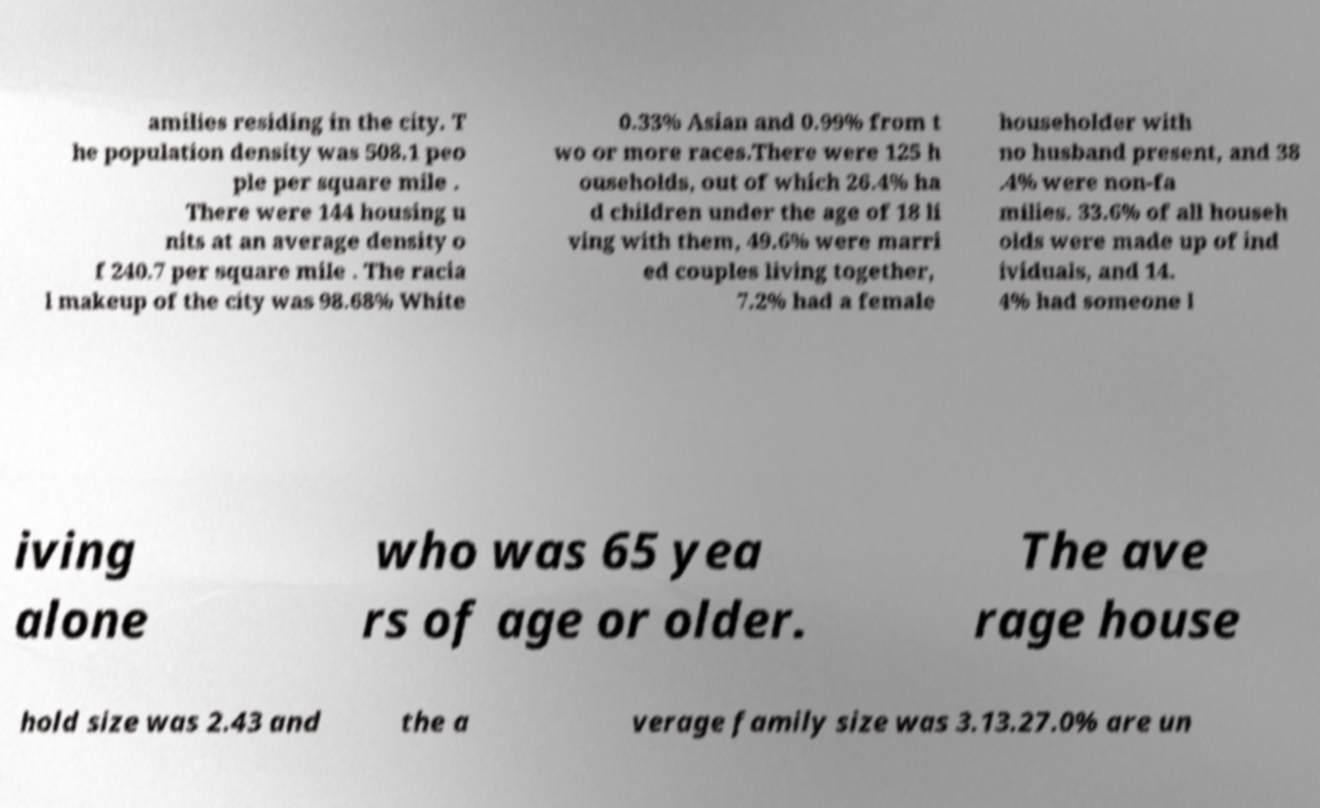What messages or text are displayed in this image? I need them in a readable, typed format. amilies residing in the city. T he population density was 508.1 peo ple per square mile . There were 144 housing u nits at an average density o f 240.7 per square mile . The racia l makeup of the city was 98.68% White 0.33% Asian and 0.99% from t wo or more races.There were 125 h ouseholds, out of which 26.4% ha d children under the age of 18 li ving with them, 49.6% were marri ed couples living together, 7.2% had a female householder with no husband present, and 38 .4% were non-fa milies. 33.6% of all househ olds were made up of ind ividuals, and 14. 4% had someone l iving alone who was 65 yea rs of age or older. The ave rage house hold size was 2.43 and the a verage family size was 3.13.27.0% are un 